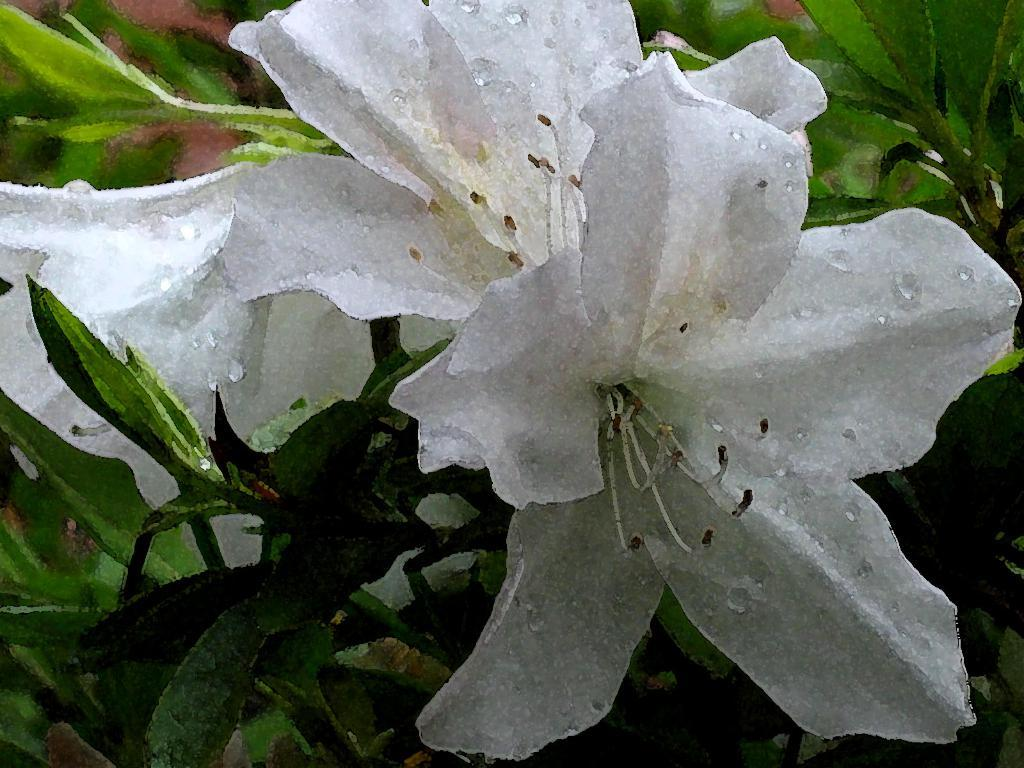What is the primary subject of the image? The image might be a painting featuring flowers. Can you describe the flowers in the image? The flowers in the image are white in color. What else can be seen in the background of the image? There are plants in the background of the image. What type of wood is used to create the pail in the image? There is no pail present in the image. Can you describe the tiger's stripes in the image? There is no tiger present in the image. 